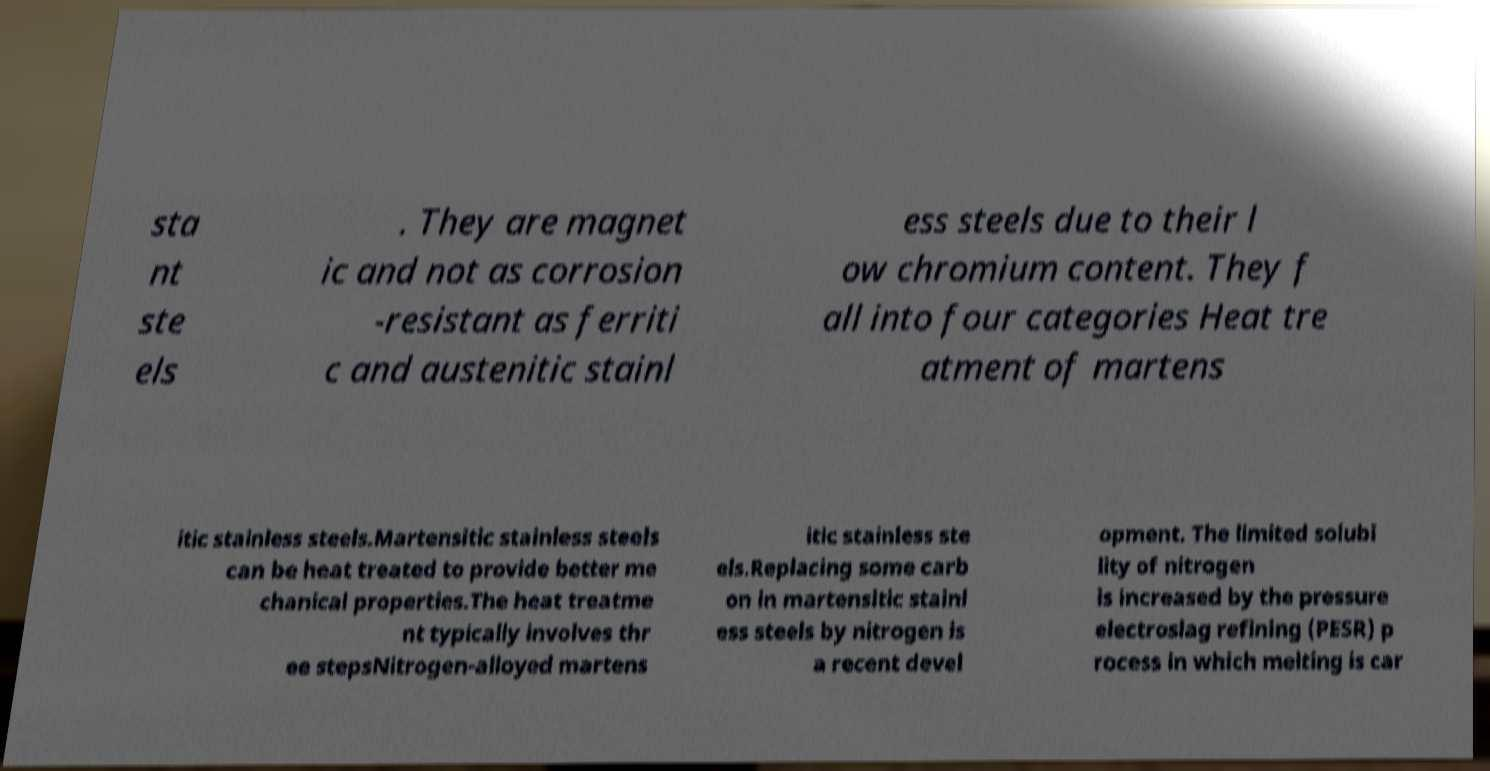I need the written content from this picture converted into text. Can you do that? sta nt ste els . They are magnet ic and not as corrosion -resistant as ferriti c and austenitic stainl ess steels due to their l ow chromium content. They f all into four categories Heat tre atment of martens itic stainless steels.Martensitic stainless steels can be heat treated to provide better me chanical properties.The heat treatme nt typically involves thr ee stepsNitrogen-alloyed martens itic stainless ste els.Replacing some carb on in martensitic stainl ess steels by nitrogen is a recent devel opment. The limited solubi lity of nitrogen is increased by the pressure electroslag refining (PESR) p rocess in which melting is car 